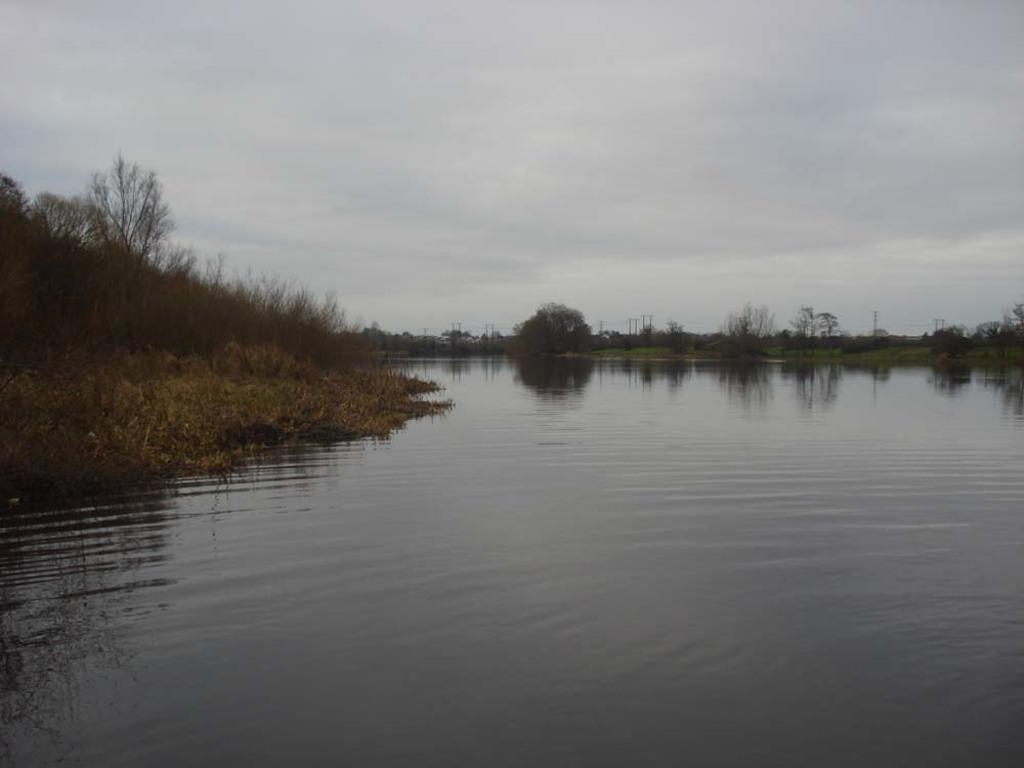Describe this image in one or two sentences. In this picture we can see water, grass, and trees. In the background there is sky. 